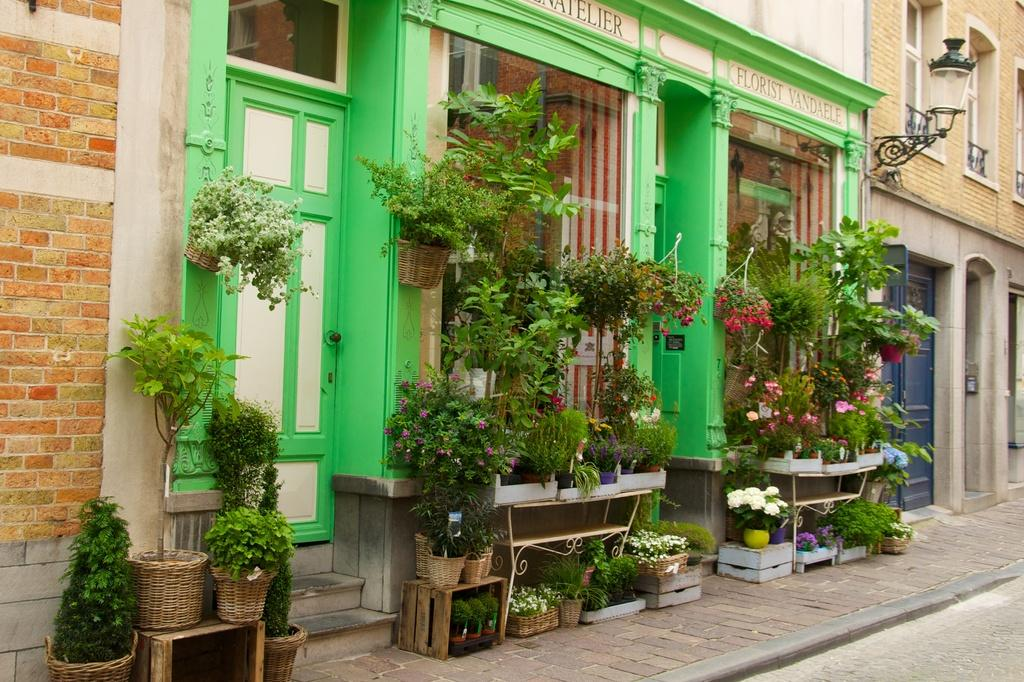What type of structures can be seen in the image? There are many buildings in the image. What can be found in the front of the image? There are potted plants in the front of the image. What is visible at the bottom of the image? There is a road and a pavement visible at the bottom of the image. What features are present on the buildings in the image? There are doors and windows in the image. How many cattle can be seen grazing on the pavement in the image? There are no cattle present in the image; it features buildings, potted plants, a road, and a pavement. What type of yak is used to measure the height of the buildings in the image? There is no yak present in the image, and yaks are not used to measure the height of buildings. 